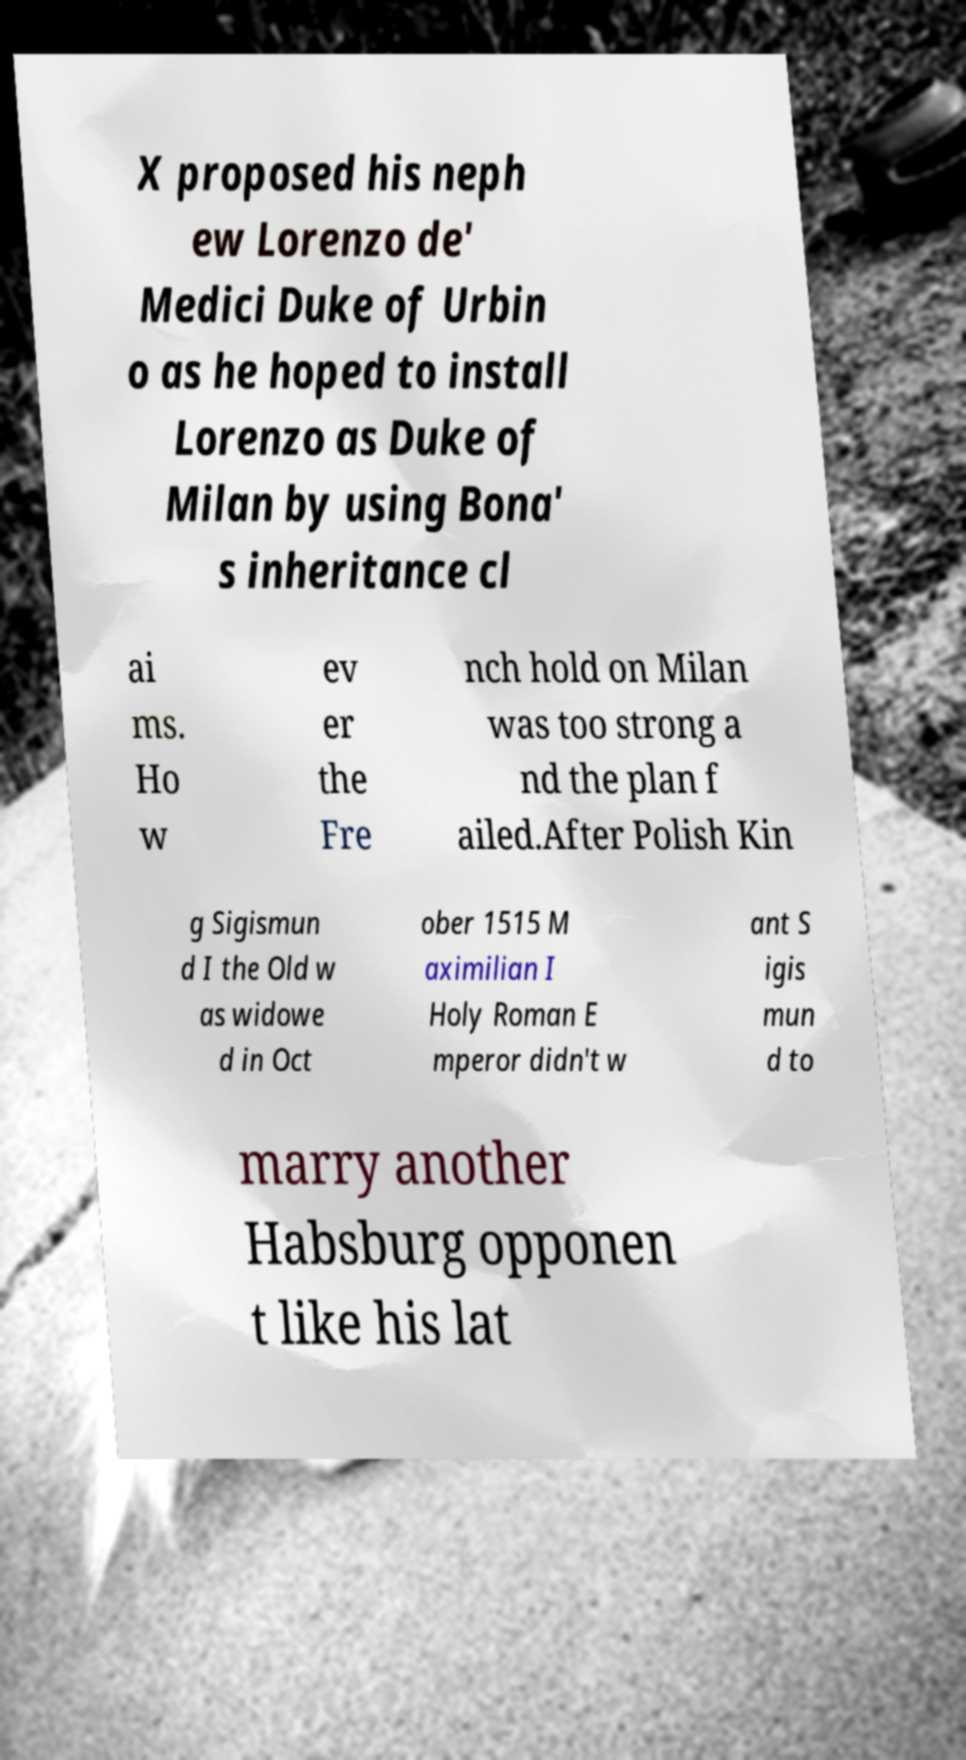For documentation purposes, I need the text within this image transcribed. Could you provide that? X proposed his neph ew Lorenzo de' Medici Duke of Urbin o as he hoped to install Lorenzo as Duke of Milan by using Bona' s inheritance cl ai ms. Ho w ev er the Fre nch hold on Milan was too strong a nd the plan f ailed.After Polish Kin g Sigismun d I the Old w as widowe d in Oct ober 1515 M aximilian I Holy Roman E mperor didn't w ant S igis mun d to marry another Habsburg opponen t like his lat 